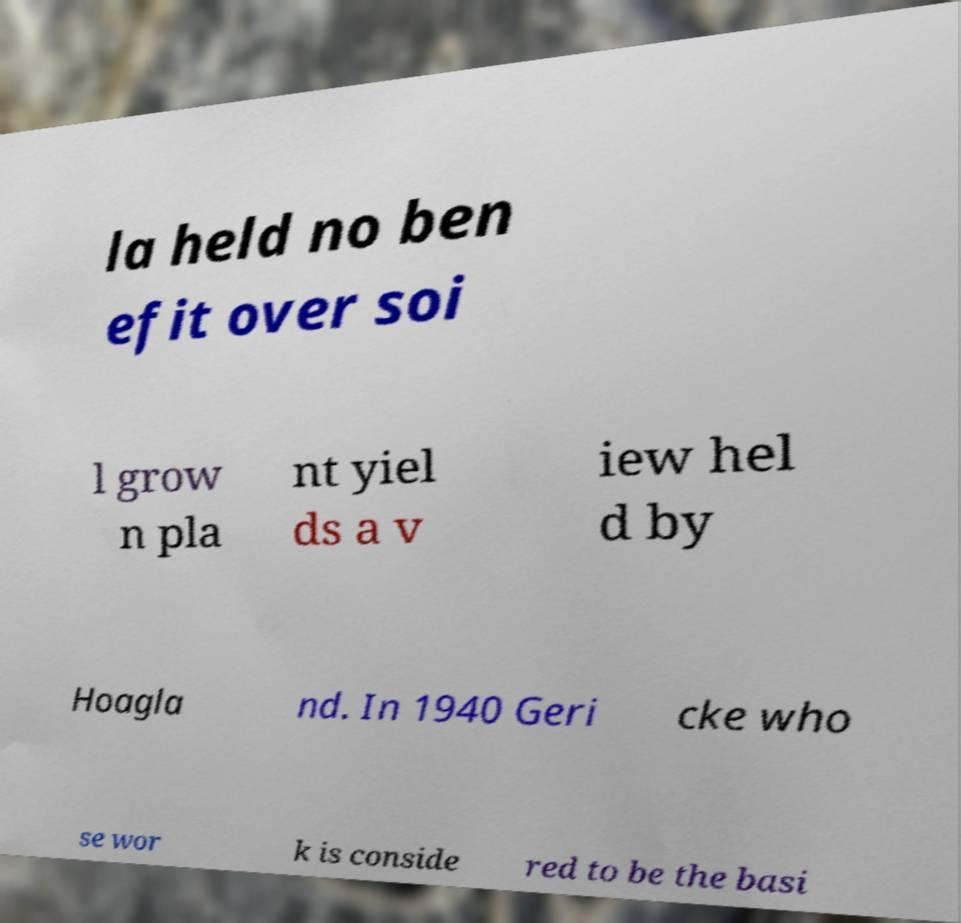I need the written content from this picture converted into text. Can you do that? la held no ben efit over soi l grow n pla nt yiel ds a v iew hel d by Hoagla nd. In 1940 Geri cke who se wor k is conside red to be the basi 